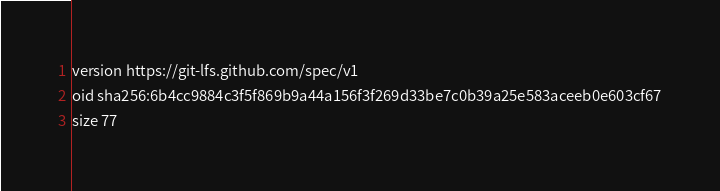<code> <loc_0><loc_0><loc_500><loc_500><_YAML_>version https://git-lfs.github.com/spec/v1
oid sha256:6b4cc9884c3f5f869b9a44a156f3f269d33be7c0b39a25e583aceeb0e603cf67
size 77
</code> 